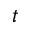Convert formula to latex. <formula><loc_0><loc_0><loc_500><loc_500>t</formula> 